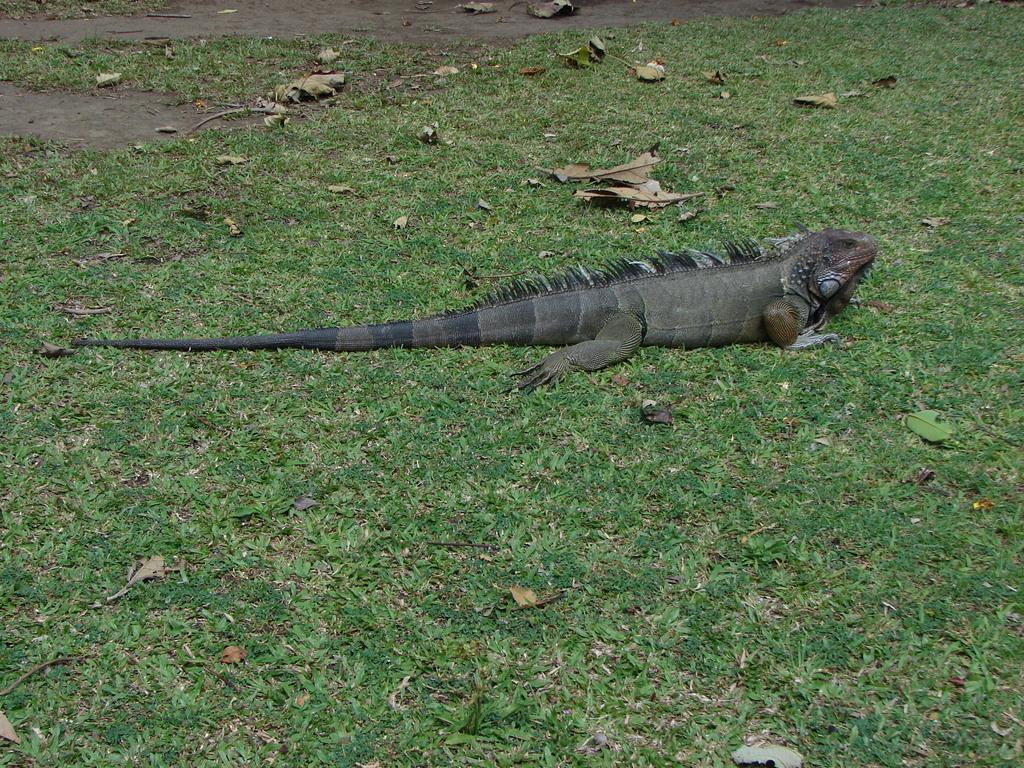Can you describe this image briefly? In the middle of the image I can see a reptile on the ground which is facing towards the right side. On the ground, I can see the green color grass and few leaves. 